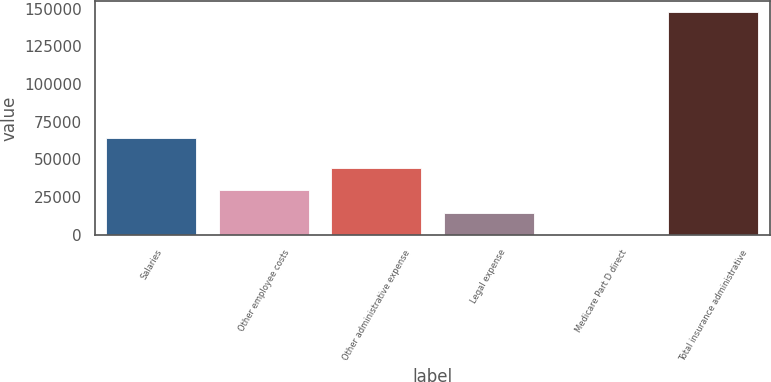<chart> <loc_0><loc_0><loc_500><loc_500><bar_chart><fcel>Salaries<fcel>Other employee costs<fcel>Other administrative expense<fcel>Legal expense<fcel>Medicare Part D direct<fcel>Total insurance administrative<nl><fcel>64339<fcel>29536.8<fcel>44304.8<fcel>14768.8<fcel>0.79<fcel>147681<nl></chart> 